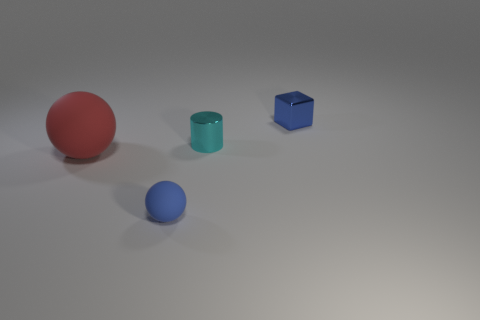Add 3 blue cylinders. How many objects exist? 7 Subtract all cylinders. How many objects are left? 3 Add 4 small blue matte balls. How many small blue matte balls are left? 5 Add 4 large blue rubber things. How many large blue rubber things exist? 4 Subtract 0 purple cylinders. How many objects are left? 4 Subtract all small shiny things. Subtract all green metallic cubes. How many objects are left? 2 